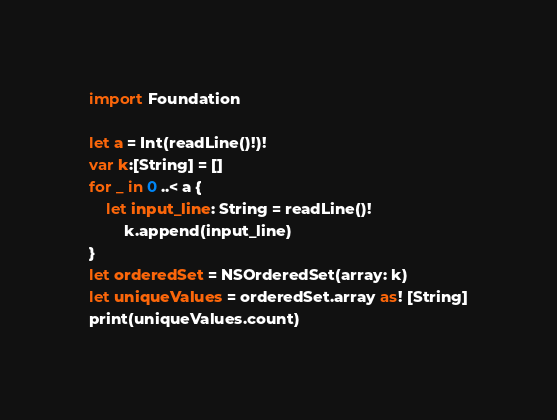Convert code to text. <code><loc_0><loc_0><loc_500><loc_500><_Swift_>import Foundation

let a = Int(readLine()!)!
var k:[String] = []
for _ in 0 ..< a {
    let input_line: String = readLine()!
        k.append(input_line)
}
let orderedSet = NSOrderedSet(array: k)
let uniqueValues = orderedSet.array as! [String]
print(uniqueValues.count)</code> 